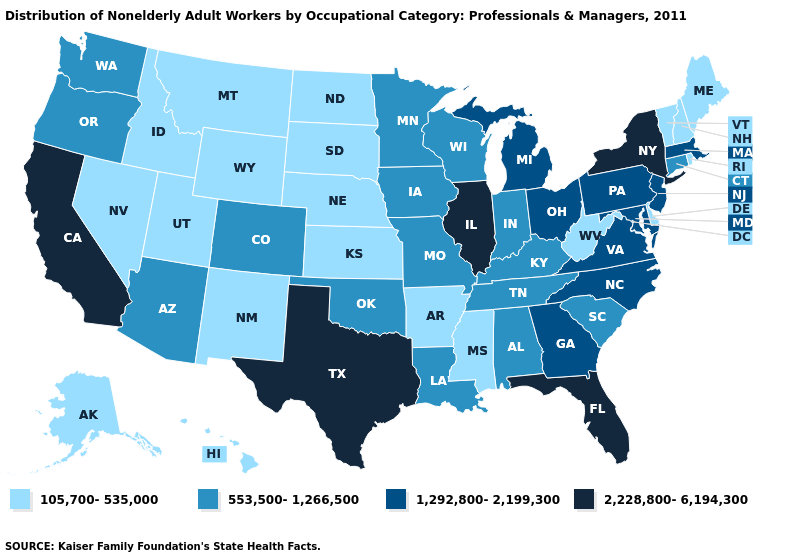Does Maryland have a lower value than New York?
Short answer required. Yes. What is the highest value in the USA?
Write a very short answer. 2,228,800-6,194,300. What is the highest value in the USA?
Be succinct. 2,228,800-6,194,300. Name the states that have a value in the range 105,700-535,000?
Write a very short answer. Alaska, Arkansas, Delaware, Hawaii, Idaho, Kansas, Maine, Mississippi, Montana, Nebraska, Nevada, New Hampshire, New Mexico, North Dakota, Rhode Island, South Dakota, Utah, Vermont, West Virginia, Wyoming. Among the states that border South Carolina , which have the lowest value?
Short answer required. Georgia, North Carolina. Does Oregon have the highest value in the West?
Give a very brief answer. No. Among the states that border Kentucky , does Missouri have the highest value?
Quick response, please. No. What is the value of Kansas?
Quick response, please. 105,700-535,000. Among the states that border Utah , which have the lowest value?
Concise answer only. Idaho, Nevada, New Mexico, Wyoming. Name the states that have a value in the range 2,228,800-6,194,300?
Concise answer only. California, Florida, Illinois, New York, Texas. Does the first symbol in the legend represent the smallest category?
Keep it brief. Yes. What is the value of Connecticut?
Short answer required. 553,500-1,266,500. Name the states that have a value in the range 553,500-1,266,500?
Write a very short answer. Alabama, Arizona, Colorado, Connecticut, Indiana, Iowa, Kentucky, Louisiana, Minnesota, Missouri, Oklahoma, Oregon, South Carolina, Tennessee, Washington, Wisconsin. Name the states that have a value in the range 2,228,800-6,194,300?
Write a very short answer. California, Florida, Illinois, New York, Texas. Name the states that have a value in the range 553,500-1,266,500?
Quick response, please. Alabama, Arizona, Colorado, Connecticut, Indiana, Iowa, Kentucky, Louisiana, Minnesota, Missouri, Oklahoma, Oregon, South Carolina, Tennessee, Washington, Wisconsin. 